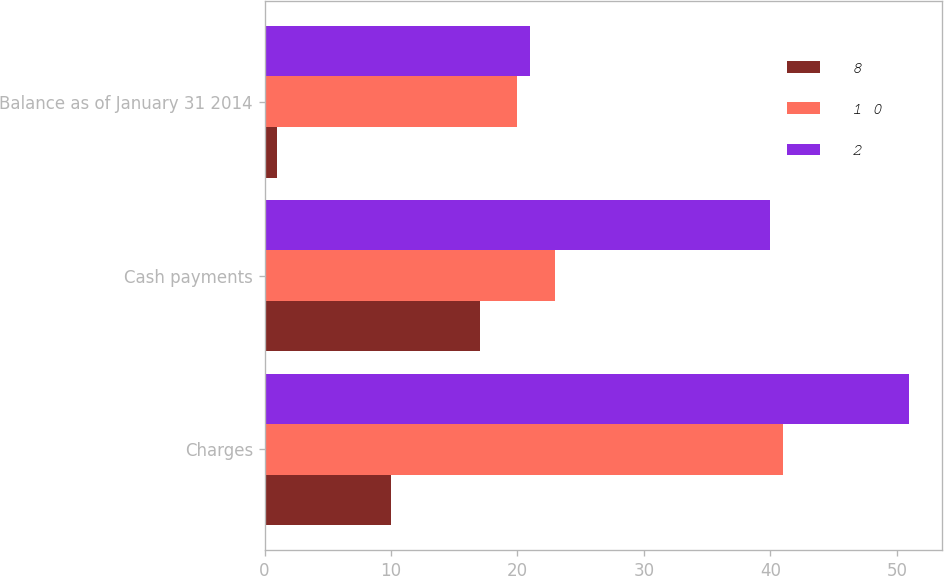<chart> <loc_0><loc_0><loc_500><loc_500><stacked_bar_chart><ecel><fcel>Charges<fcel>Cash payments<fcel>Balance as of January 31 2014<nl><fcel>8<fcel>10<fcel>17<fcel>1<nl><fcel>1 0<fcel>41<fcel>23<fcel>20<nl><fcel>2<fcel>51<fcel>40<fcel>21<nl></chart> 